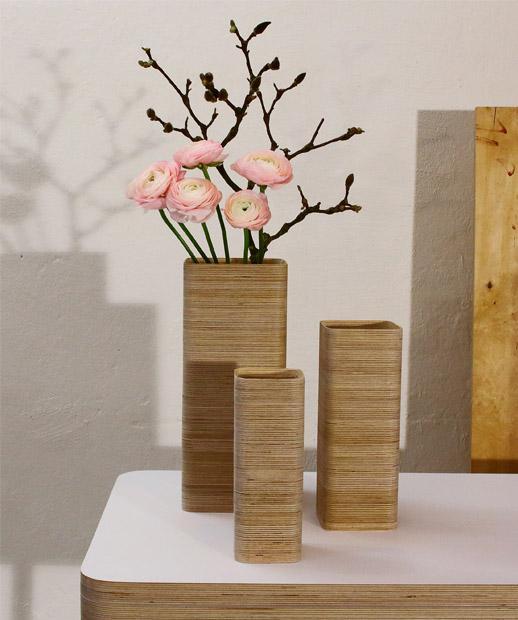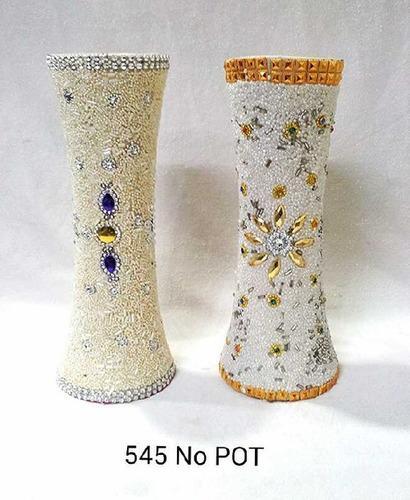The first image is the image on the left, the second image is the image on the right. Given the left and right images, does the statement "There is one empty vase in the image on the right." hold true? Answer yes or no. No. The first image is the image on the left, the second image is the image on the right. For the images shown, is this caption "In one image, a single vase has four box-like sides that are smaller at the bottom than at the top, while one vase in a second image is dark brown and curved." true? Answer yes or no. No. 